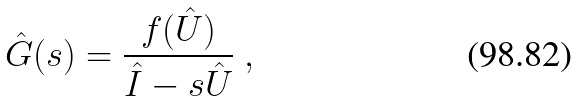Convert formula to latex. <formula><loc_0><loc_0><loc_500><loc_500>\hat { G } ( s ) = \frac { f ( \hat { U } ) } { \hat { I } - s \hat { U } } \ ,</formula> 